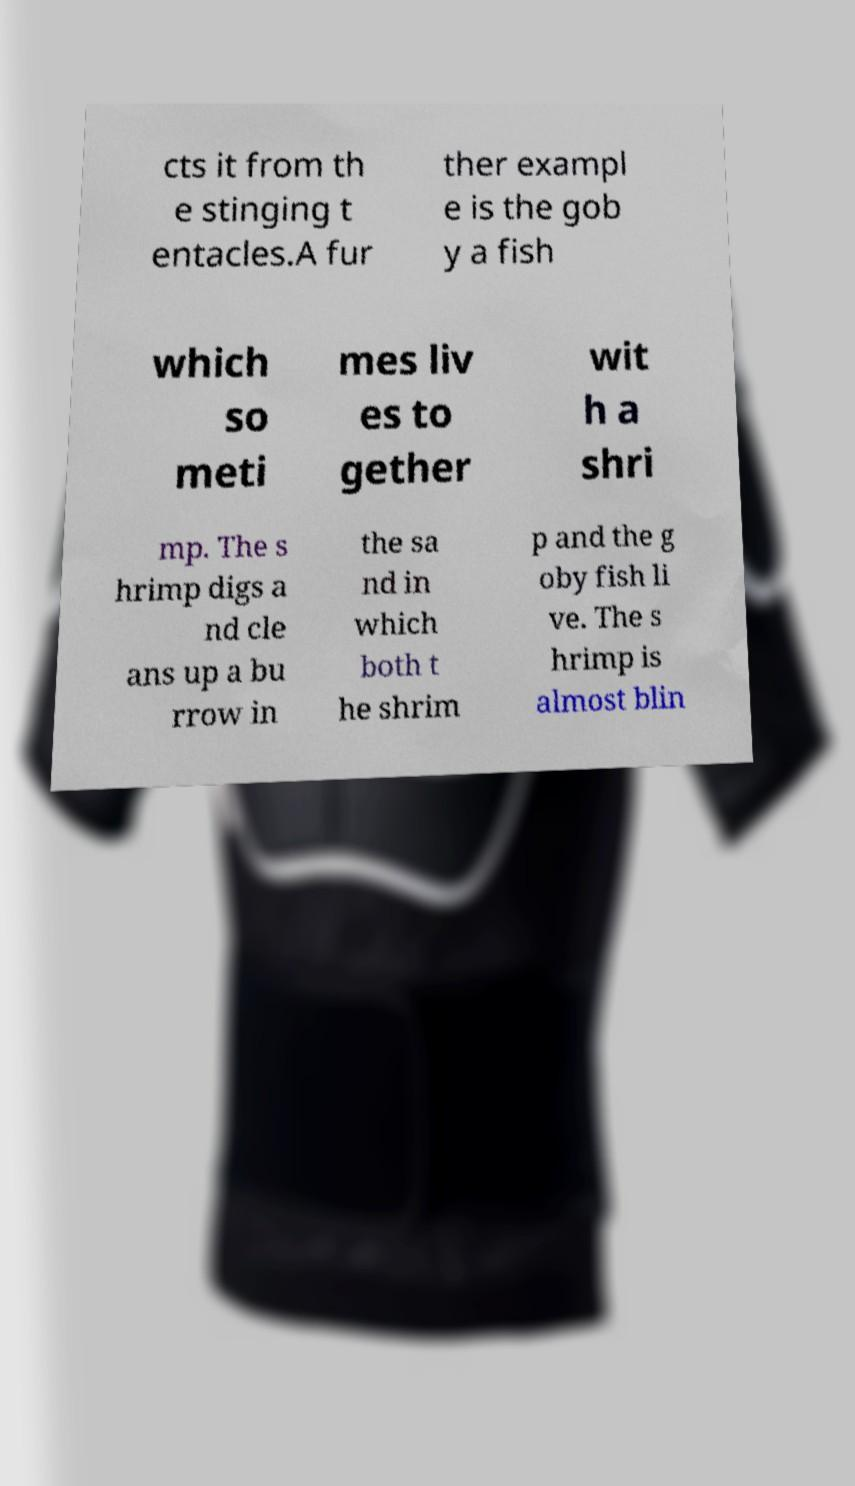Please identify and transcribe the text found in this image. cts it from th e stinging t entacles.A fur ther exampl e is the gob y a fish which so meti mes liv es to gether wit h a shri mp. The s hrimp digs a nd cle ans up a bu rrow in the sa nd in which both t he shrim p and the g oby fish li ve. The s hrimp is almost blin 